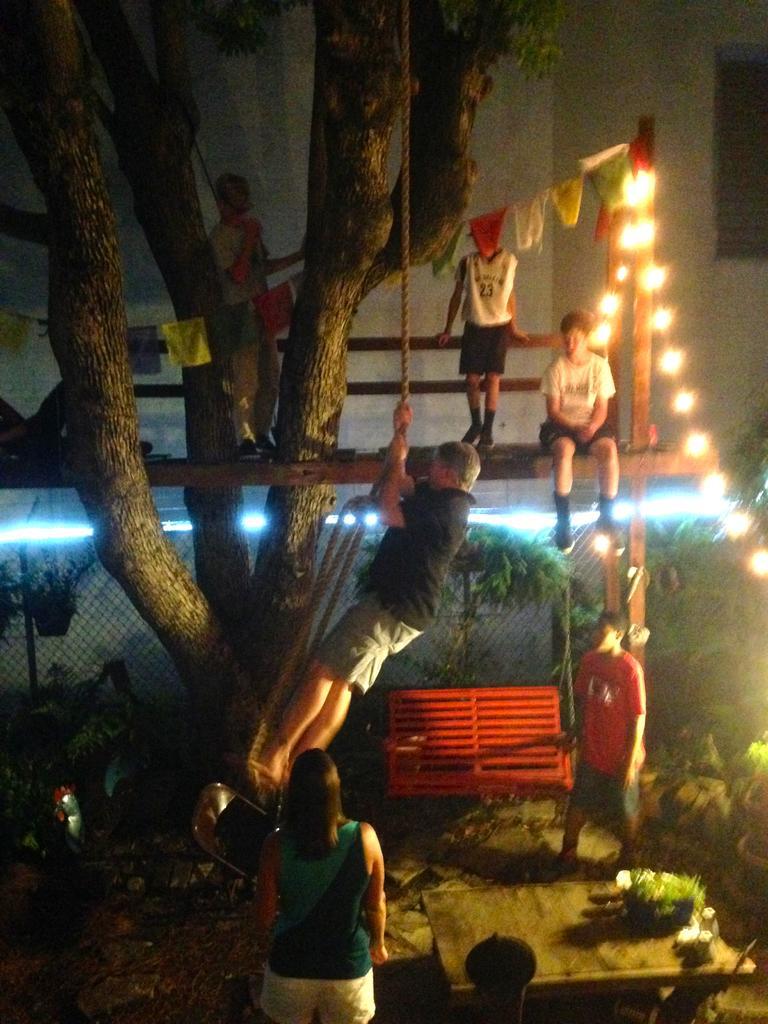Describe this image in one or two sentences. In this picture we can see there are two people standing on the path and on the path there is a table, bench and a chair and a man in the black t shirt is holding a rope. Two people are standing and a person is sitting on a wooden object and to the object there are some decorative items and lights. Behind the people there is a fence, plants, wall and a tree. 